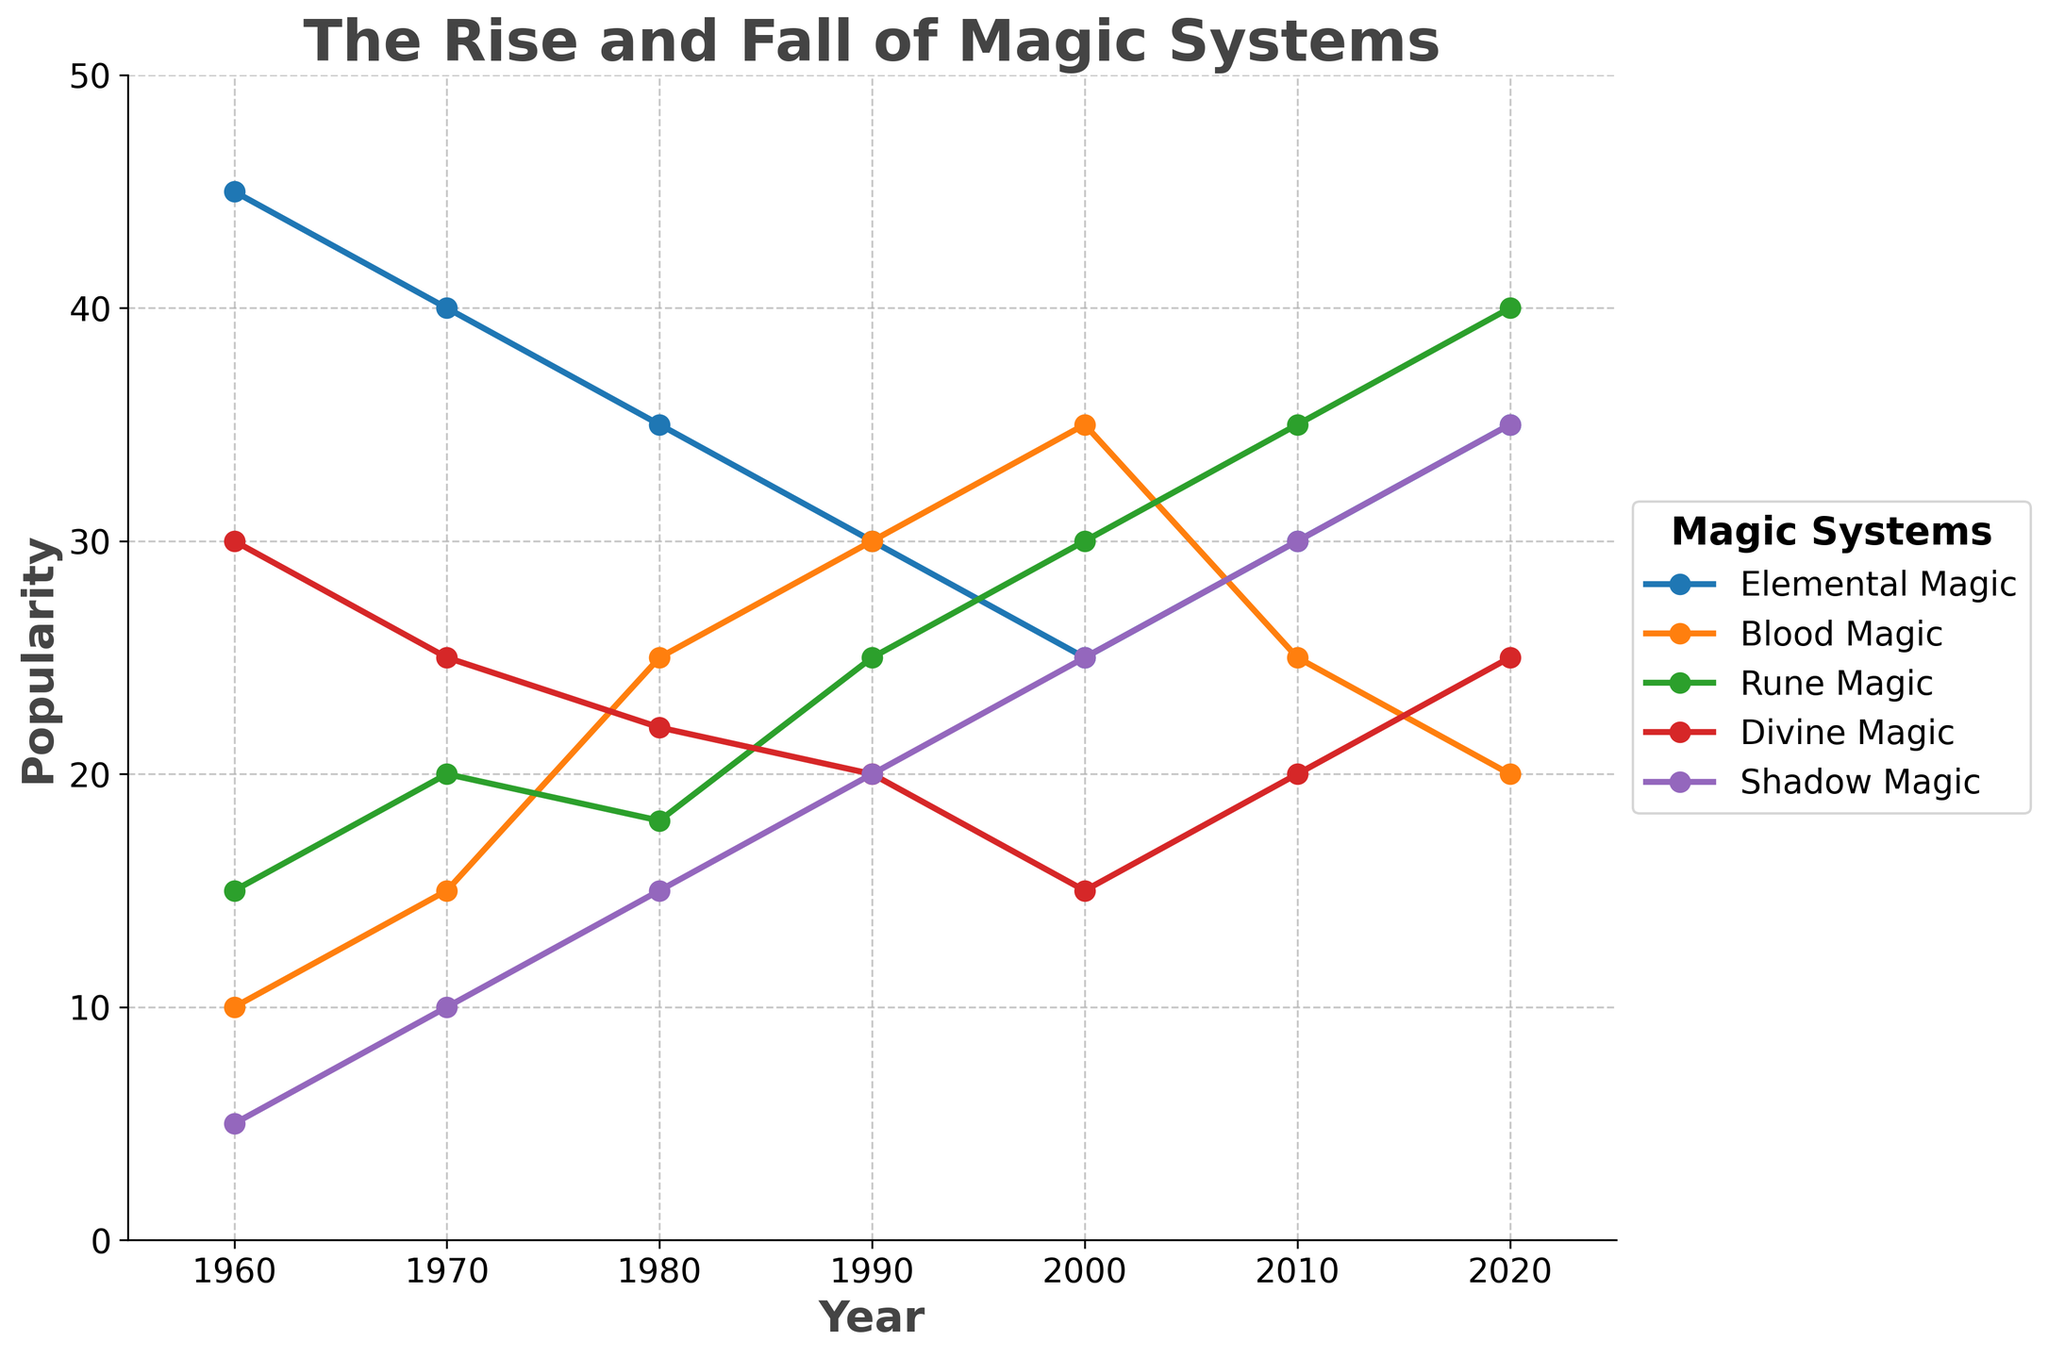Which magic system demonstrated the highest increase in popularity between two consecutive decades? Shadow Magic shows an increase from 5 in 1960 to 10 in 1970, and then a steady rise until 2020 where it reaches 35. The increase from 5 to 35 between these points is the largest observed among all magic systems in successive decades.
Answer: Shadow Magic Which magic system had the lowest popularity in 1970? In 1970, the data shows that Shadow Magic had the lowest popularity with a value of 10. Comparatively, all other magic systems had higher values.
Answer: Shadow Magic Between 2000 and 2020, did Blood Magic's popularity generally increase or decrease? The data shows that Blood Magic decreased from 35 in 2000 to 25 in 2010, followed by a further decrease to 20 in 2020. Thus, the overall trend between 2000 and 2020 is a decrease.
Answer: Decrease What was the combined popularity of Elemental Magic and Divine Magic in 1980? In 1980, the popularity for Elemental Magic was 35 and for Divine Magic was 22. Combined, this makes 35 + 22 = 57.
Answer: 57 Which magic system had the greatest decline in popularity between 1960 and 2000? Looking at the data, Elemental Magic shows the most significant decline from 45 in 1960 to 25 in 2000. This is a decline of 20, which is the largest drop among all magic systems in this period.
Answer: Elemental Magic How does the popularity of Rune Magic in 2020 compare to its popularity in 1960? In 1960, Rune Magic had a popularity of 15, and it increased to 40 by 2020. Comparing these two values, we see an increase of 40 - 15 = 25.
Answer: Increased by 25 Which two magic systems had similar popularity trends from 1990 to 2000? From 1990 to 2000, both Elemental Magic and Divine Magic show a similar declining trend. Elemental Magic goes from 30 to 25, and Divine Magic from 20 to 15, both showing a decrease over these years.
Answer: Elemental and Divine Magic What is the average popularity of Shadow Magic across all decades provided? Summing up the popularity of Shadow Magic for each decade given (5 + 10 + 15 + 20 + 25 + 30 + 35) = 140. Dividing by the number of decades, which is 7, we get 140 / 7 = 20.
Answer: 20 Which magic system maintained a relatively stable popularity throughout the decades? Divine Magic experiences fluctuations but shows a moderate trend compared to others: 30 in 1960, 25 in 1970, 22 in 1980, 20 in 1990, 15 in 2000, 20 in 2010, and 25 in 2020. Though it shows declines and increases, the changes are comparatively smaller.
Answer: Divine Magic 